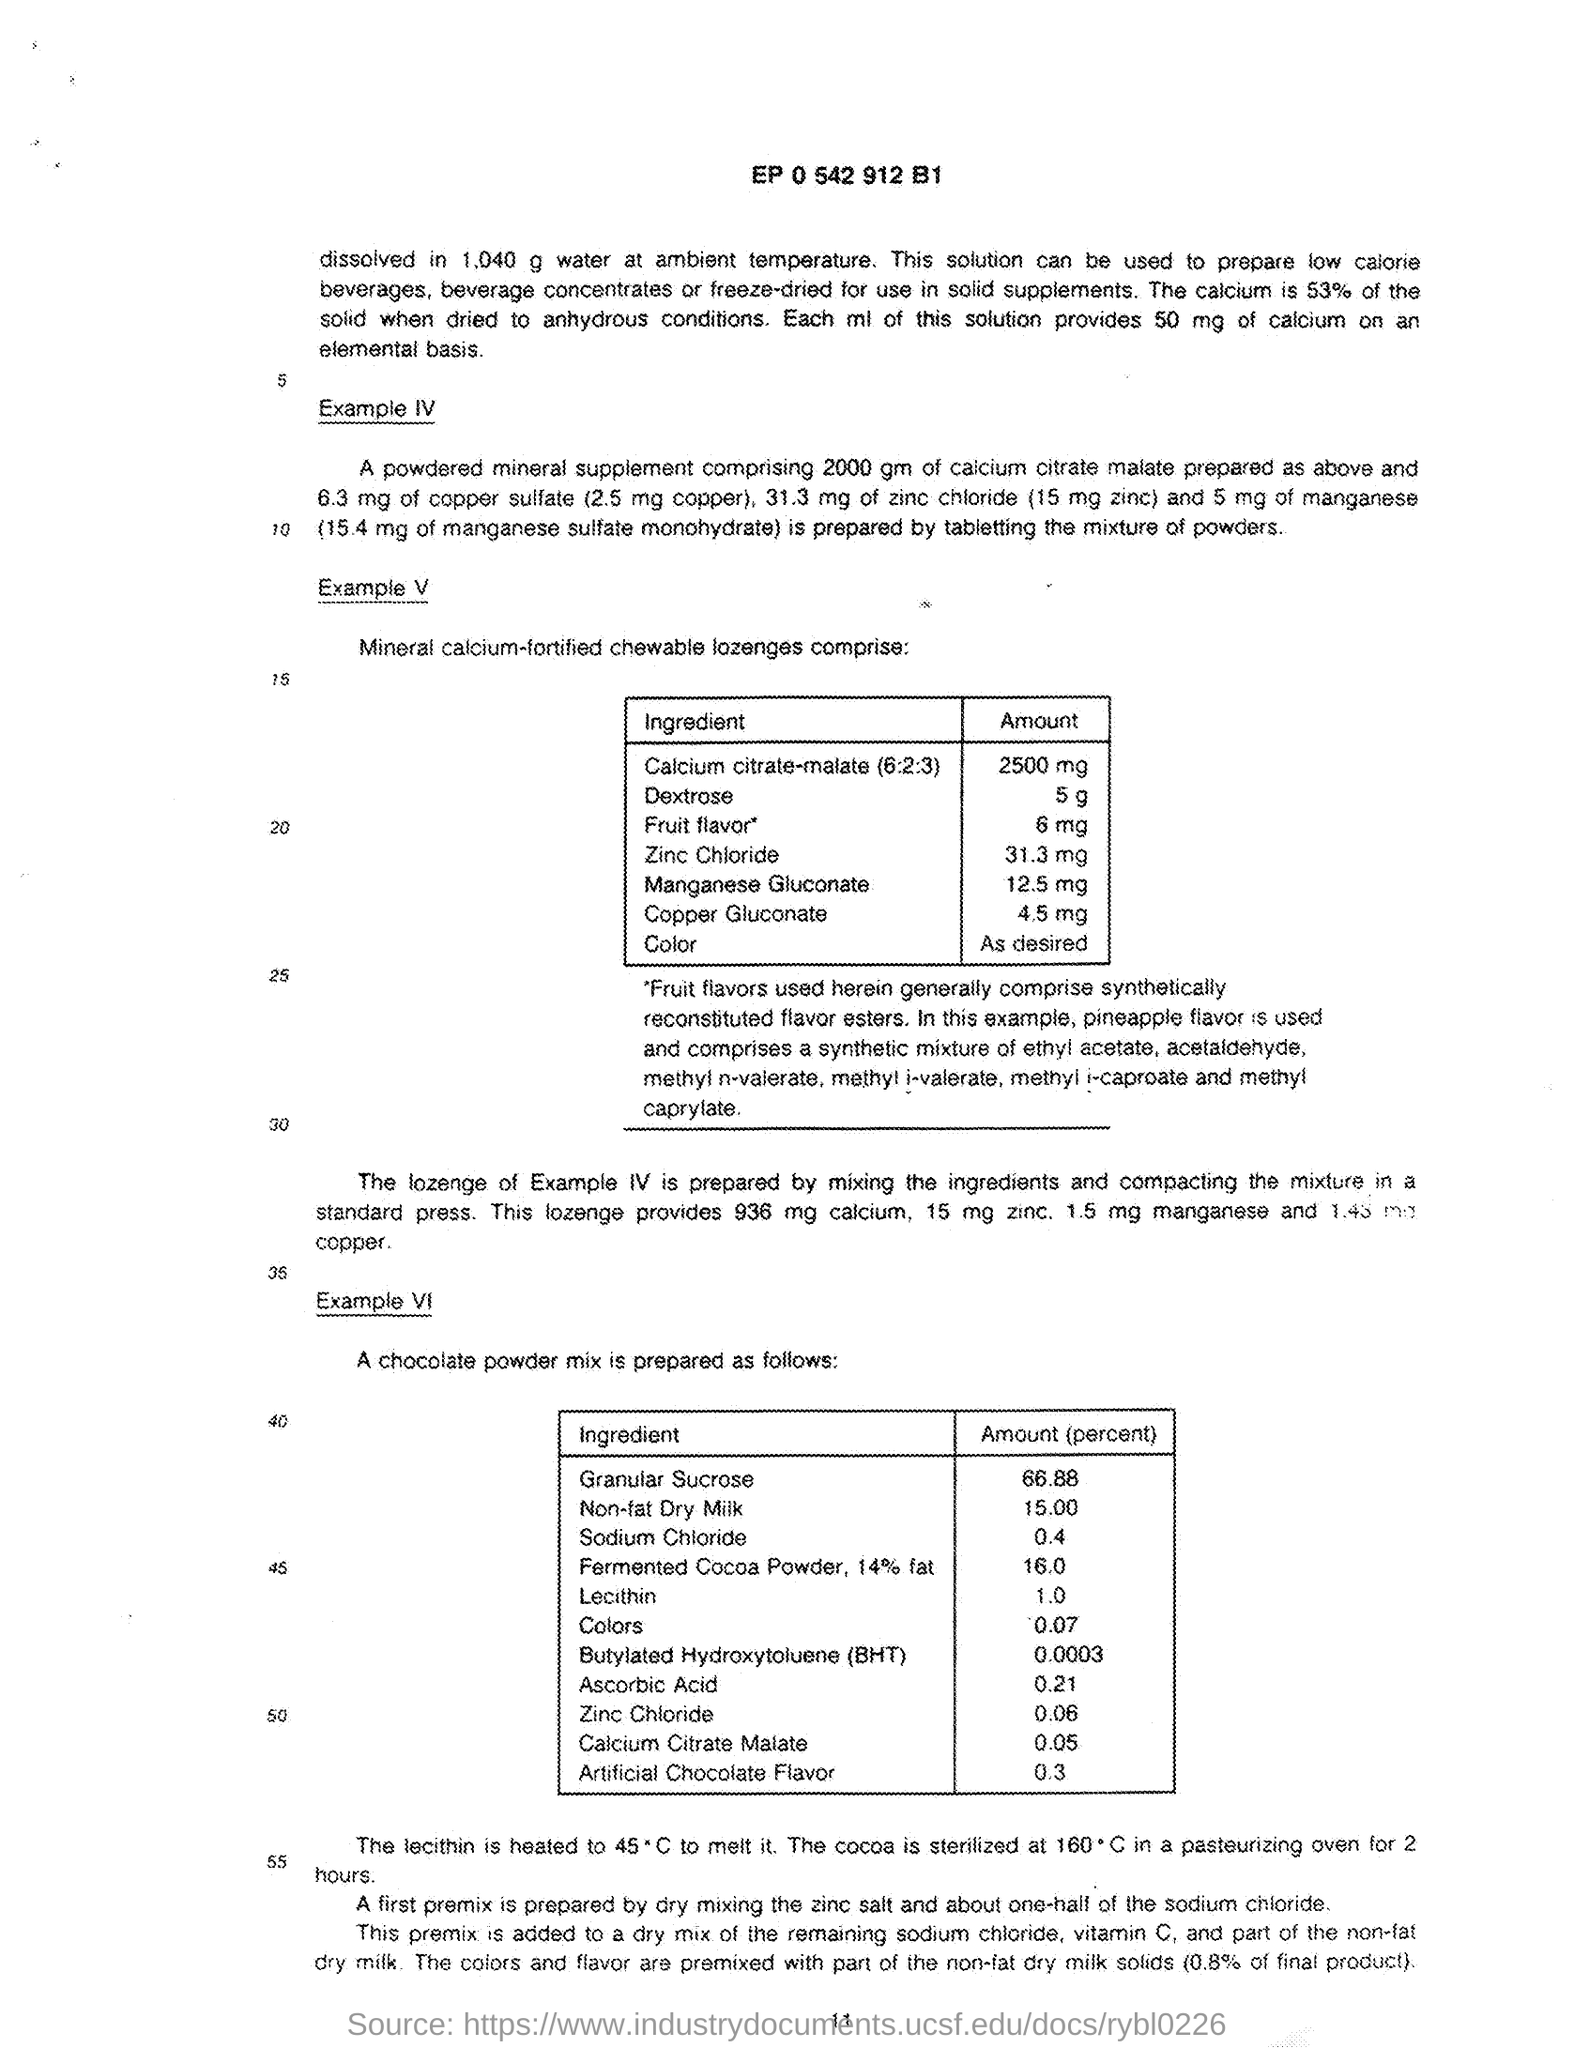Point out several critical features in this image. The amount of Zinc Chloride present in mineral calcium-fortified chewable lozenges as given in Example V is 31.3 mg. The ingredient with a quantity of 12.5mg is present in mineral calcium-fortified chewable lozenges, as specified in Example V, and it is Manganese Gluconate. The granular sucrose content in the chocolate powder mix, as described in Example VI, is 66.88%. The amount of non-fat dry milk present in a chocolate powder mix, as specified in Example VI, is 15.00%. The ingredient with a amount of 2500mg that is present in mineral calcium-fortified chewable lozenges, as given in Example V, is calcium citrate-malate (6:2:3). 